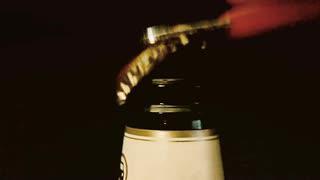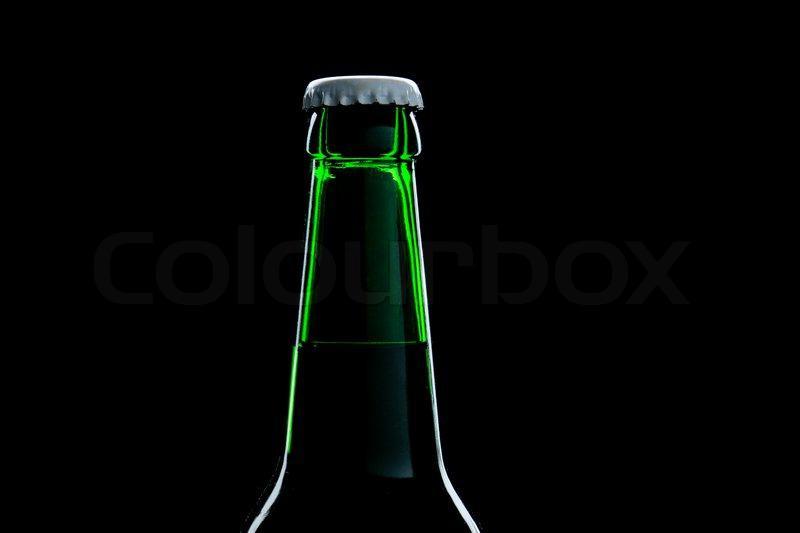The first image is the image on the left, the second image is the image on the right. For the images shown, is this caption "An image shows the neck of a green bottle." true? Answer yes or no. Yes. 